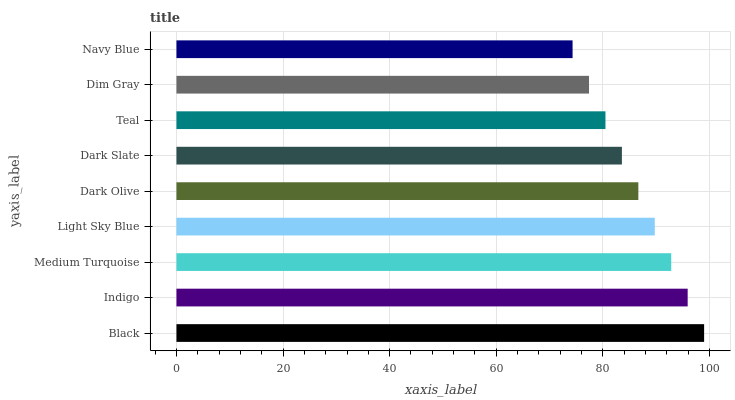Is Navy Blue the minimum?
Answer yes or no. Yes. Is Black the maximum?
Answer yes or no. Yes. Is Indigo the minimum?
Answer yes or no. No. Is Indigo the maximum?
Answer yes or no. No. Is Black greater than Indigo?
Answer yes or no. Yes. Is Indigo less than Black?
Answer yes or no. Yes. Is Indigo greater than Black?
Answer yes or no. No. Is Black less than Indigo?
Answer yes or no. No. Is Dark Olive the high median?
Answer yes or no. Yes. Is Dark Olive the low median?
Answer yes or no. Yes. Is Black the high median?
Answer yes or no. No. Is Dark Slate the low median?
Answer yes or no. No. 